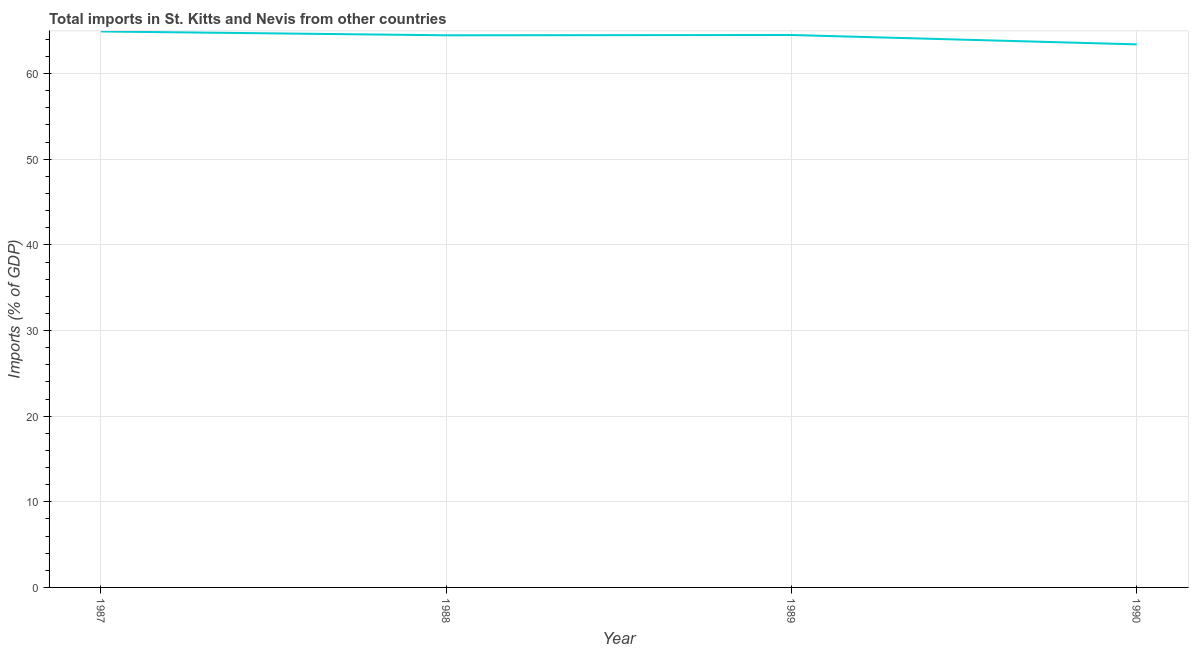What is the total imports in 1990?
Your answer should be very brief. 63.41. Across all years, what is the maximum total imports?
Provide a succinct answer. 64.92. Across all years, what is the minimum total imports?
Keep it short and to the point. 63.41. In which year was the total imports maximum?
Offer a terse response. 1987. In which year was the total imports minimum?
Provide a succinct answer. 1990. What is the sum of the total imports?
Offer a terse response. 257.32. What is the difference between the total imports in 1987 and 1988?
Ensure brevity in your answer.  0.45. What is the average total imports per year?
Offer a very short reply. 64.33. What is the median total imports?
Your answer should be compact. 64.49. Do a majority of the years between 1990 and 1987 (inclusive) have total imports greater than 50 %?
Give a very brief answer. Yes. What is the ratio of the total imports in 1988 to that in 1990?
Your answer should be very brief. 1.02. What is the difference between the highest and the second highest total imports?
Offer a terse response. 0.41. Is the sum of the total imports in 1987 and 1989 greater than the maximum total imports across all years?
Your answer should be very brief. Yes. What is the difference between the highest and the lowest total imports?
Provide a succinct answer. 1.51. Does the total imports monotonically increase over the years?
Your response must be concise. No. How many lines are there?
Offer a terse response. 1. How many years are there in the graph?
Provide a short and direct response. 4. What is the difference between two consecutive major ticks on the Y-axis?
Provide a succinct answer. 10. Are the values on the major ticks of Y-axis written in scientific E-notation?
Offer a very short reply. No. What is the title of the graph?
Make the answer very short. Total imports in St. Kitts and Nevis from other countries. What is the label or title of the Y-axis?
Provide a short and direct response. Imports (% of GDP). What is the Imports (% of GDP) of 1987?
Offer a very short reply. 64.92. What is the Imports (% of GDP) in 1988?
Your answer should be compact. 64.47. What is the Imports (% of GDP) of 1989?
Provide a succinct answer. 64.51. What is the Imports (% of GDP) of 1990?
Keep it short and to the point. 63.41. What is the difference between the Imports (% of GDP) in 1987 and 1988?
Your response must be concise. 0.45. What is the difference between the Imports (% of GDP) in 1987 and 1989?
Ensure brevity in your answer.  0.41. What is the difference between the Imports (% of GDP) in 1987 and 1990?
Offer a very short reply. 1.51. What is the difference between the Imports (% of GDP) in 1988 and 1989?
Ensure brevity in your answer.  -0.04. What is the difference between the Imports (% of GDP) in 1988 and 1990?
Your response must be concise. 1.06. What is the difference between the Imports (% of GDP) in 1989 and 1990?
Provide a short and direct response. 1.1. What is the ratio of the Imports (% of GDP) in 1987 to that in 1988?
Provide a succinct answer. 1.01. What is the ratio of the Imports (% of GDP) in 1987 to that in 1989?
Your response must be concise. 1.01. What is the ratio of the Imports (% of GDP) in 1988 to that in 1989?
Offer a terse response. 1. What is the ratio of the Imports (% of GDP) in 1989 to that in 1990?
Offer a terse response. 1.02. 